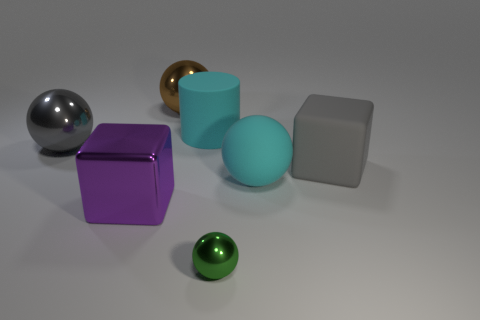What is the shape of the tiny object that is made of the same material as the large purple object?
Give a very brief answer. Sphere. Do the big brown object and the gray block that is right of the brown ball have the same material?
Keep it short and to the point. No. Does the big matte thing that is to the left of the small ball have the same shape as the brown metal object?
Ensure brevity in your answer.  No. What is the material of the cyan thing that is the same shape as the green shiny object?
Make the answer very short. Rubber. There is a large gray metallic thing; is its shape the same as the cyan matte thing that is right of the cylinder?
Ensure brevity in your answer.  Yes. What is the color of the big ball that is to the left of the big matte ball and right of the large purple metal cube?
Your answer should be very brief. Brown. Are any large metallic cubes visible?
Offer a very short reply. Yes. Is the number of large brown metallic spheres left of the metallic block the same as the number of small yellow cylinders?
Give a very brief answer. Yes. How many other objects are the same shape as the large brown metal object?
Offer a very short reply. 3. The large purple metallic object is what shape?
Ensure brevity in your answer.  Cube. 